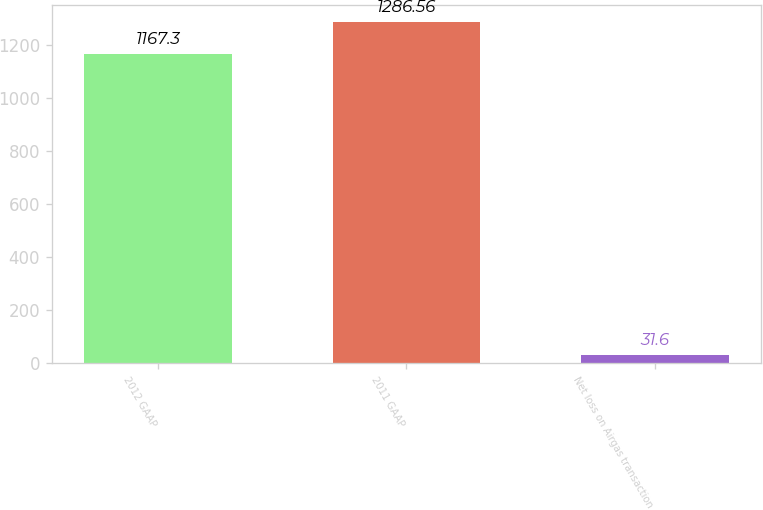<chart> <loc_0><loc_0><loc_500><loc_500><bar_chart><fcel>2012 GAAP<fcel>2011 GAAP<fcel>Net loss on Airgas transaction<nl><fcel>1167.3<fcel>1286.56<fcel>31.6<nl></chart> 